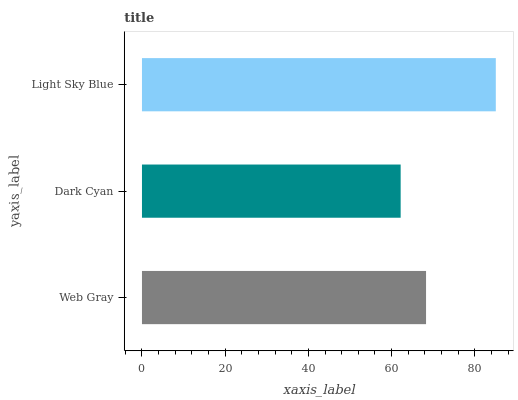Is Dark Cyan the minimum?
Answer yes or no. Yes. Is Light Sky Blue the maximum?
Answer yes or no. Yes. Is Light Sky Blue the minimum?
Answer yes or no. No. Is Dark Cyan the maximum?
Answer yes or no. No. Is Light Sky Blue greater than Dark Cyan?
Answer yes or no. Yes. Is Dark Cyan less than Light Sky Blue?
Answer yes or no. Yes. Is Dark Cyan greater than Light Sky Blue?
Answer yes or no. No. Is Light Sky Blue less than Dark Cyan?
Answer yes or no. No. Is Web Gray the high median?
Answer yes or no. Yes. Is Web Gray the low median?
Answer yes or no. Yes. Is Light Sky Blue the high median?
Answer yes or no. No. Is Dark Cyan the low median?
Answer yes or no. No. 